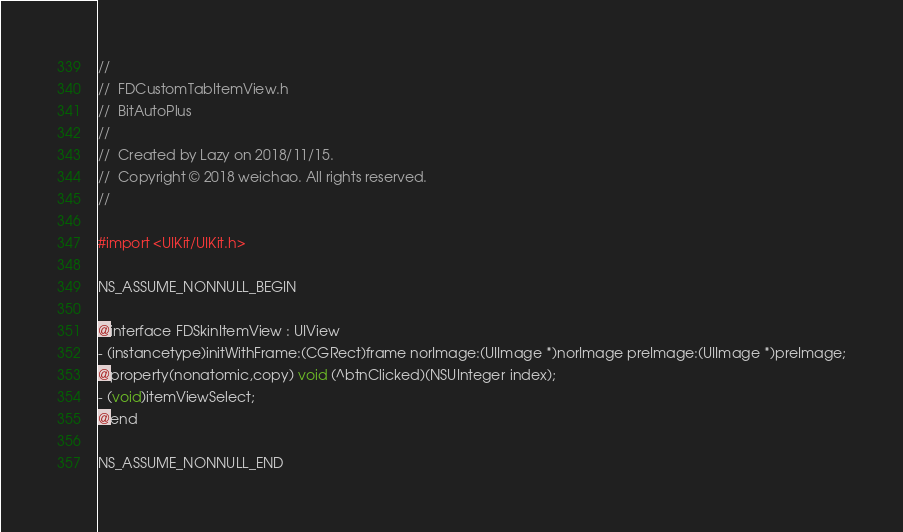Convert code to text. <code><loc_0><loc_0><loc_500><loc_500><_C_>//
//  FDCustomTabItemView.h
//  BitAutoPlus
//
//  Created by Lazy on 2018/11/15.
//  Copyright © 2018 weichao. All rights reserved.
//

#import <UIKit/UIKit.h>

NS_ASSUME_NONNULL_BEGIN

@interface FDSkinItemView : UIView
- (instancetype)initWithFrame:(CGRect)frame norImage:(UIImage *)norImage preImage:(UIImage *)preImage;
@property(nonatomic,copy) void (^btnClicked)(NSUInteger index);
- (void)itemViewSelect;
@end

NS_ASSUME_NONNULL_END
</code> 